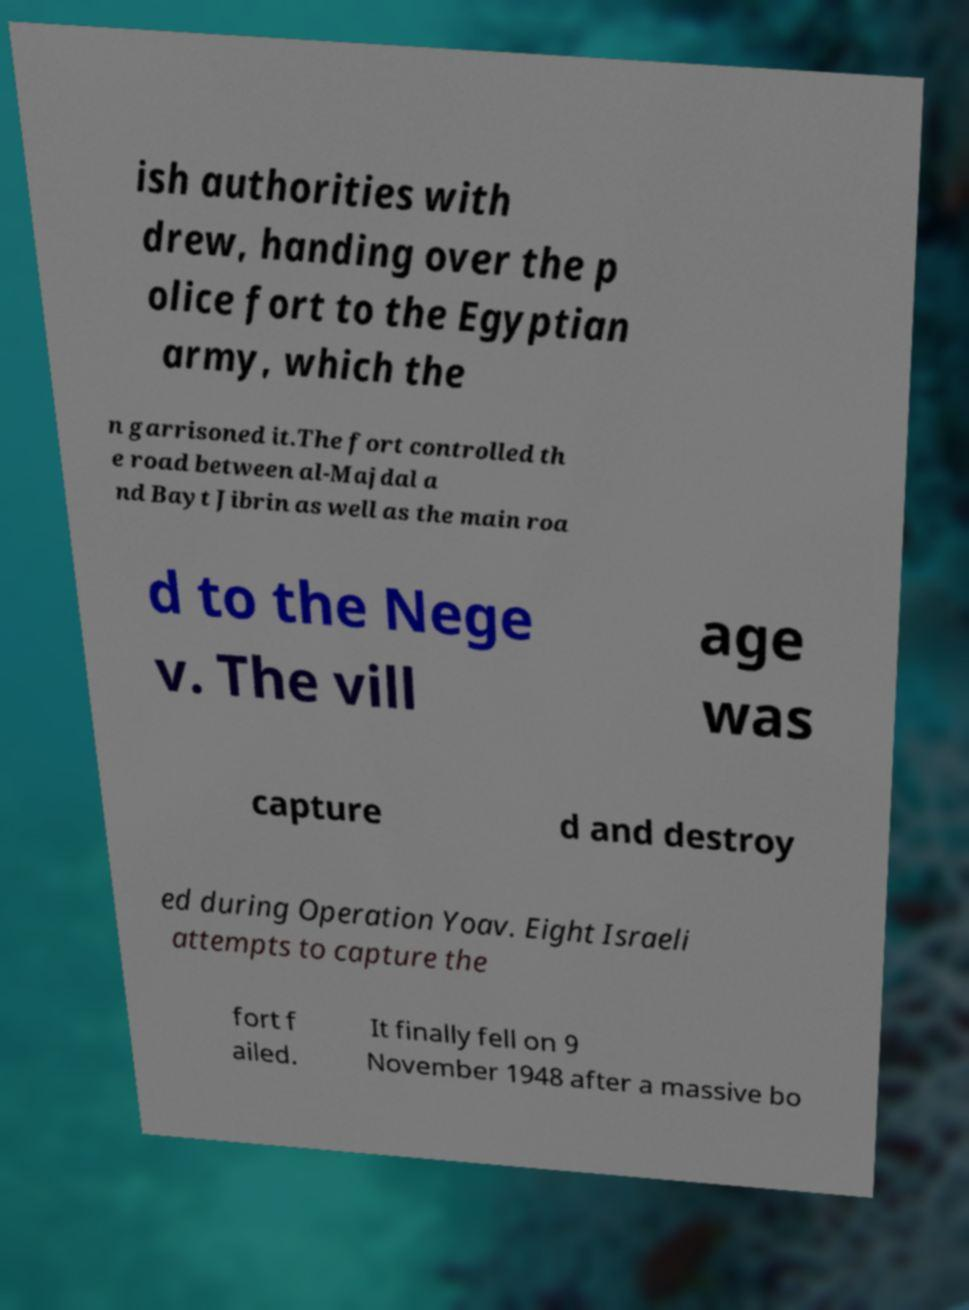There's text embedded in this image that I need extracted. Can you transcribe it verbatim? ish authorities with drew, handing over the p olice fort to the Egyptian army, which the n garrisoned it.The fort controlled th e road between al-Majdal a nd Bayt Jibrin as well as the main roa d to the Nege v. The vill age was capture d and destroy ed during Operation Yoav. Eight Israeli attempts to capture the fort f ailed. It finally fell on 9 November 1948 after a massive bo 